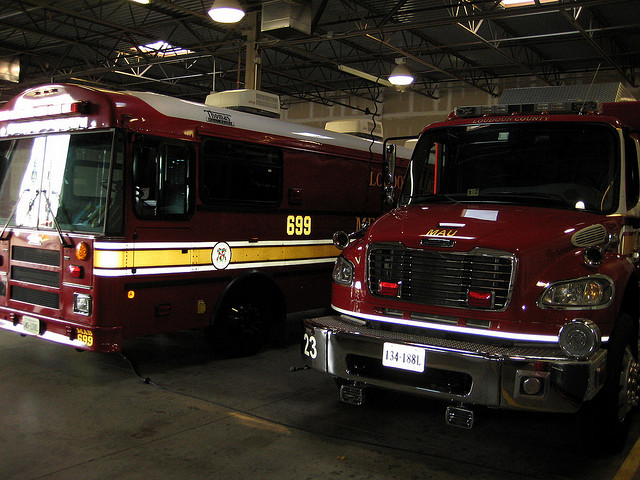Please extract the text content from this image. 699 MAU 1881 23 COUNTY 